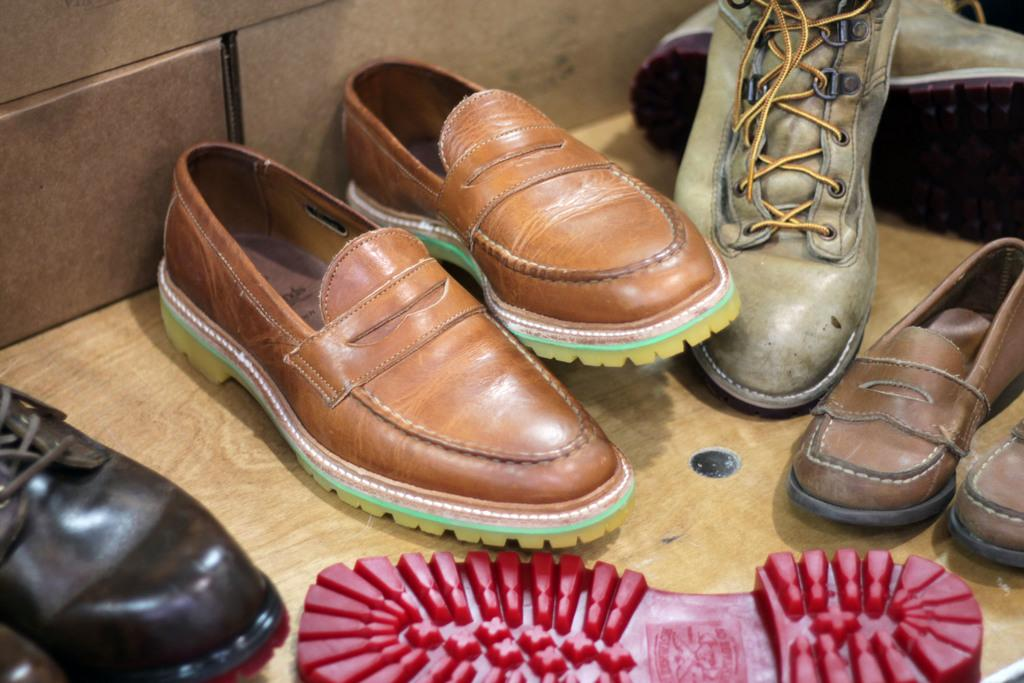What objects are in the image? There are shoes in the image. Where are the shoes placed? The shoes are on a wooden surface. What can be seen in the background of the image? There is a wall in the image. Can you hear the owl talking in the image? There is no owl or talking in the image; it only features shoes on a wooden surface with a wall in the background. 